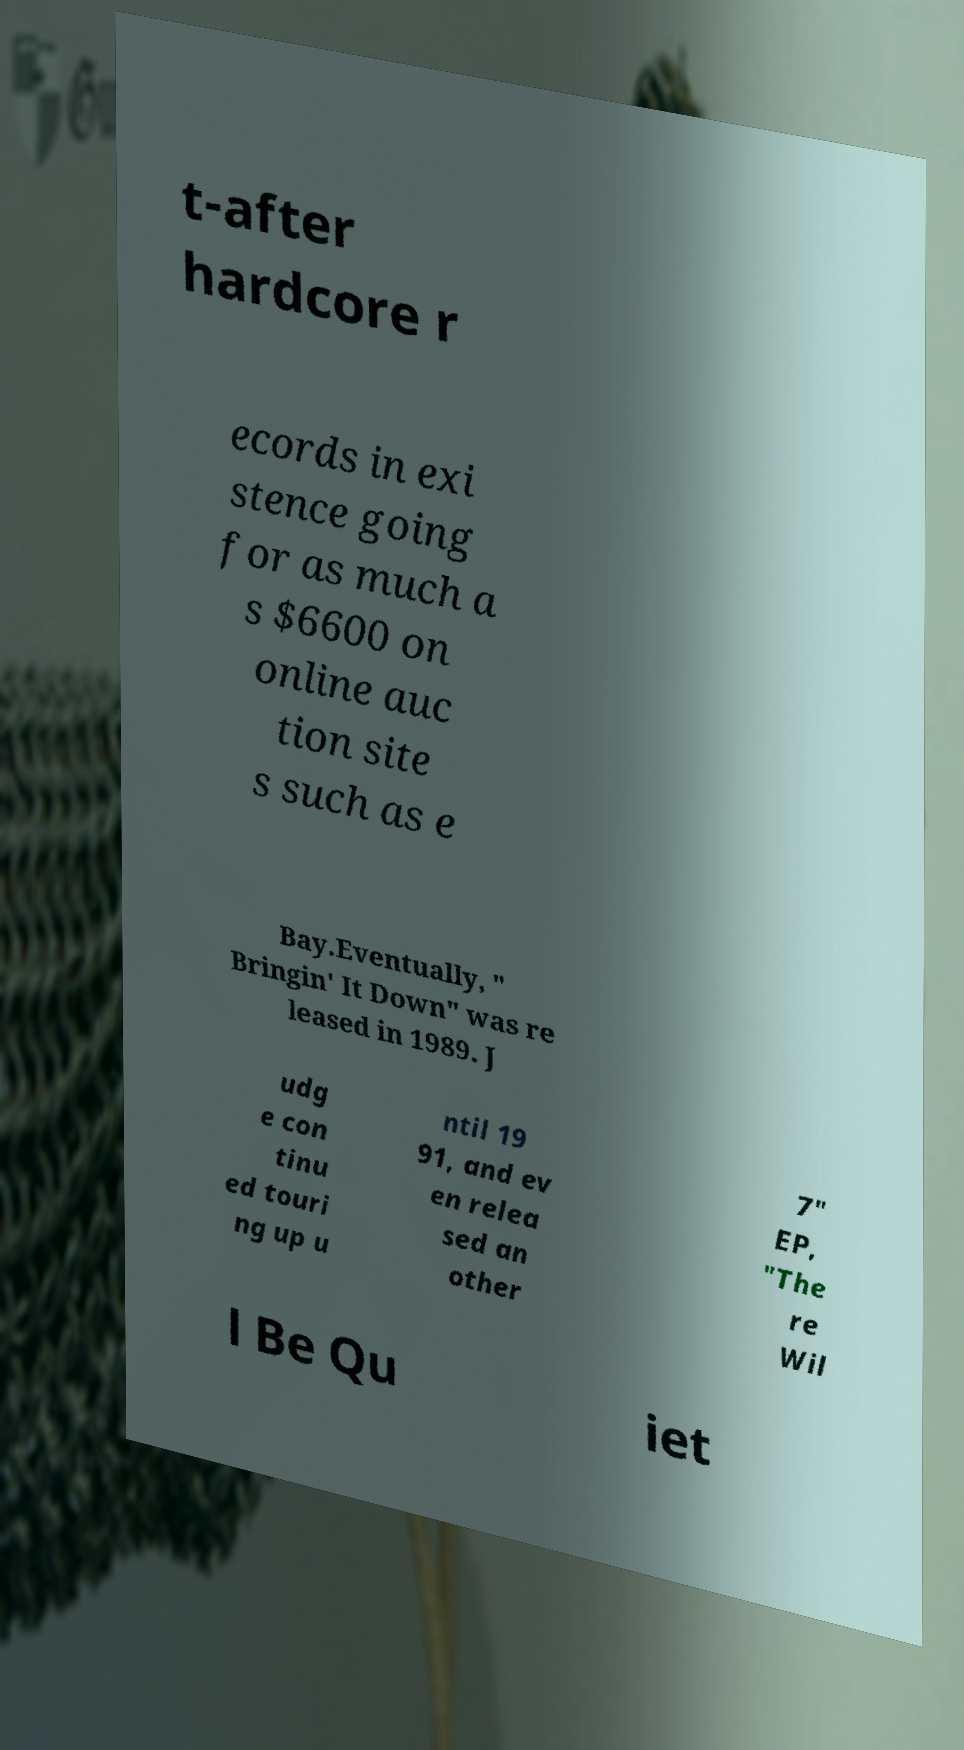Please read and relay the text visible in this image. What does it say? t-after hardcore r ecords in exi stence going for as much a s $6600 on online auc tion site s such as e Bay.Eventually, " Bringin' It Down" was re leased in 1989. J udg e con tinu ed touri ng up u ntil 19 91, and ev en relea sed an other 7" EP, "The re Wil l Be Qu iet 